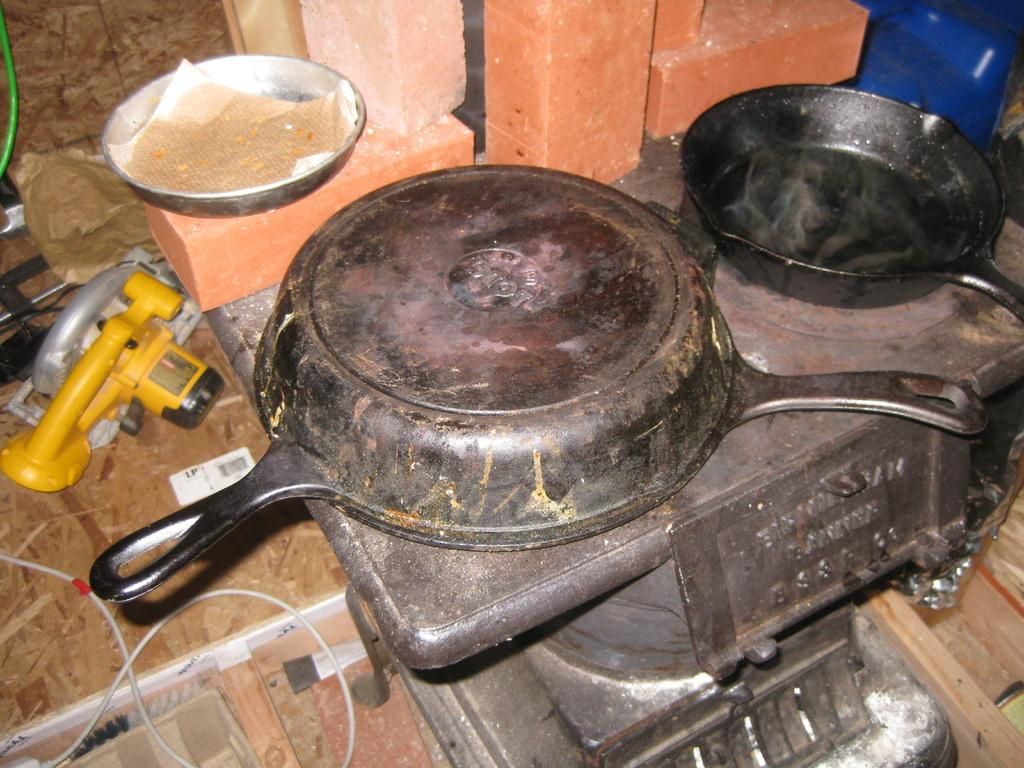What is on the stand in the image? There are containers on a stand in the image. What else can be seen in the image besides the containers? There is a wire in the image. What is visible in the background of the image? There is a wall and a blue object in the background of the image. Can you see any bats flying around in the image? There are no bats visible in the image. 